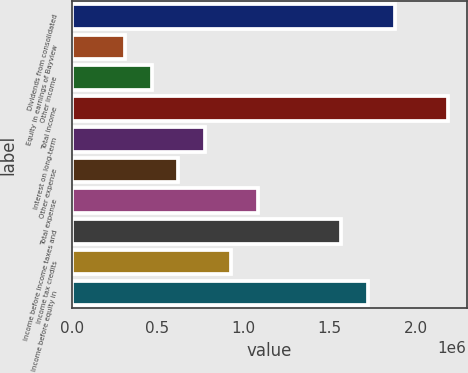<chart> <loc_0><loc_0><loc_500><loc_500><bar_chart><fcel>Dividends from consolidated<fcel>Equity in earnings of Bayview<fcel>Other income<fcel>Total income<fcel>Interest on long-term<fcel>Other expense<fcel>Total expense<fcel>Income before income taxes and<fcel>Income tax credits<fcel>Income before equity in<nl><fcel>1.87819e+06<fcel>309976<fcel>464960<fcel>2.18815e+06<fcel>774927<fcel>619943<fcel>1.08489e+06<fcel>1.56822e+06<fcel>929910<fcel>1.7232e+06<nl></chart> 